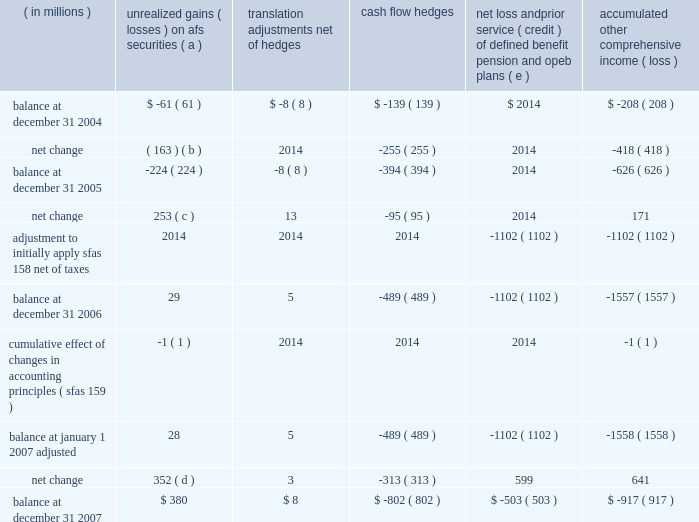Notes to consolidated financial statements jpmorgan chase & co .
162 jpmorgan chase & co .
/ 2007 annual report note 25 2013 accumulated other comprehensive income ( loss ) accumulated other comprehensive income ( loss ) includes the after-tax change in sfas 115 unrealized gains and losses on afs securities , sfas 52 foreign currency translation adjustments ( including the impact of related derivatives ) , sfas 133 cash flow hedging activities and sfas 158 net loss and prior service cost ( credit ) related to the firm 2019s defined benefit pension and opeb plans .
Net loss and accumulated translation prior service ( credit ) of other unrealized gains ( losses ) adjustments , cash defined benefit pension comprehensive ( in millions ) on afs securities ( a ) net of hedges flow hedges and opeb plans ( e ) income ( loss ) balance at december 31 , 2004 $ ( 61 ) $ ( 8 ) $ ( 139 ) $ 2014 $ ( 208 ) net change ( 163 ) ( b ) 2014 ( 255 ) 2014 ( 418 ) balance at december 31 , 2005 ( 224 ) ( 8 ) ( 394 ) 2014 ( 626 ) net change 253 ( c ) 13 ( 95 ) 2014 171 adjustment to initially apply sfas 158 , net of taxes 2014 2014 2014 ( 1102 ) ( 1102 ) .
Net change 352 ( d ) 3 ( 313 ) 599 641 balance at december 31 , 2007 $ 380 $ 8 $ ( 802 ) $ ( 503 ) $ ( 917 ) ( a ) represents the after-tax difference between the fair value and amortized cost of the afs securities portfolio and retained interests in securitizations recorded in other assets .
( b ) the net change during 2005 was due primarily to higher interest rates , partially offset by the reversal of unrealized losses from securities sales .
( c ) the net change during 2006 was due primarily to the reversal of unrealized losses from securities sales .
( d ) the net change during 2007 was due primarily to a decline in interest rates .
( e ) for further discussion of sfas 158 , see note 9 on pages 124 2013130 of this annual report. .
What was the percentage change in unrealized gains ( losses ) on afs securities from december 31 , 2006 to december 31 , 2007? 
Computations: ((380 - 29) / 29)
Answer: 12.10345. 